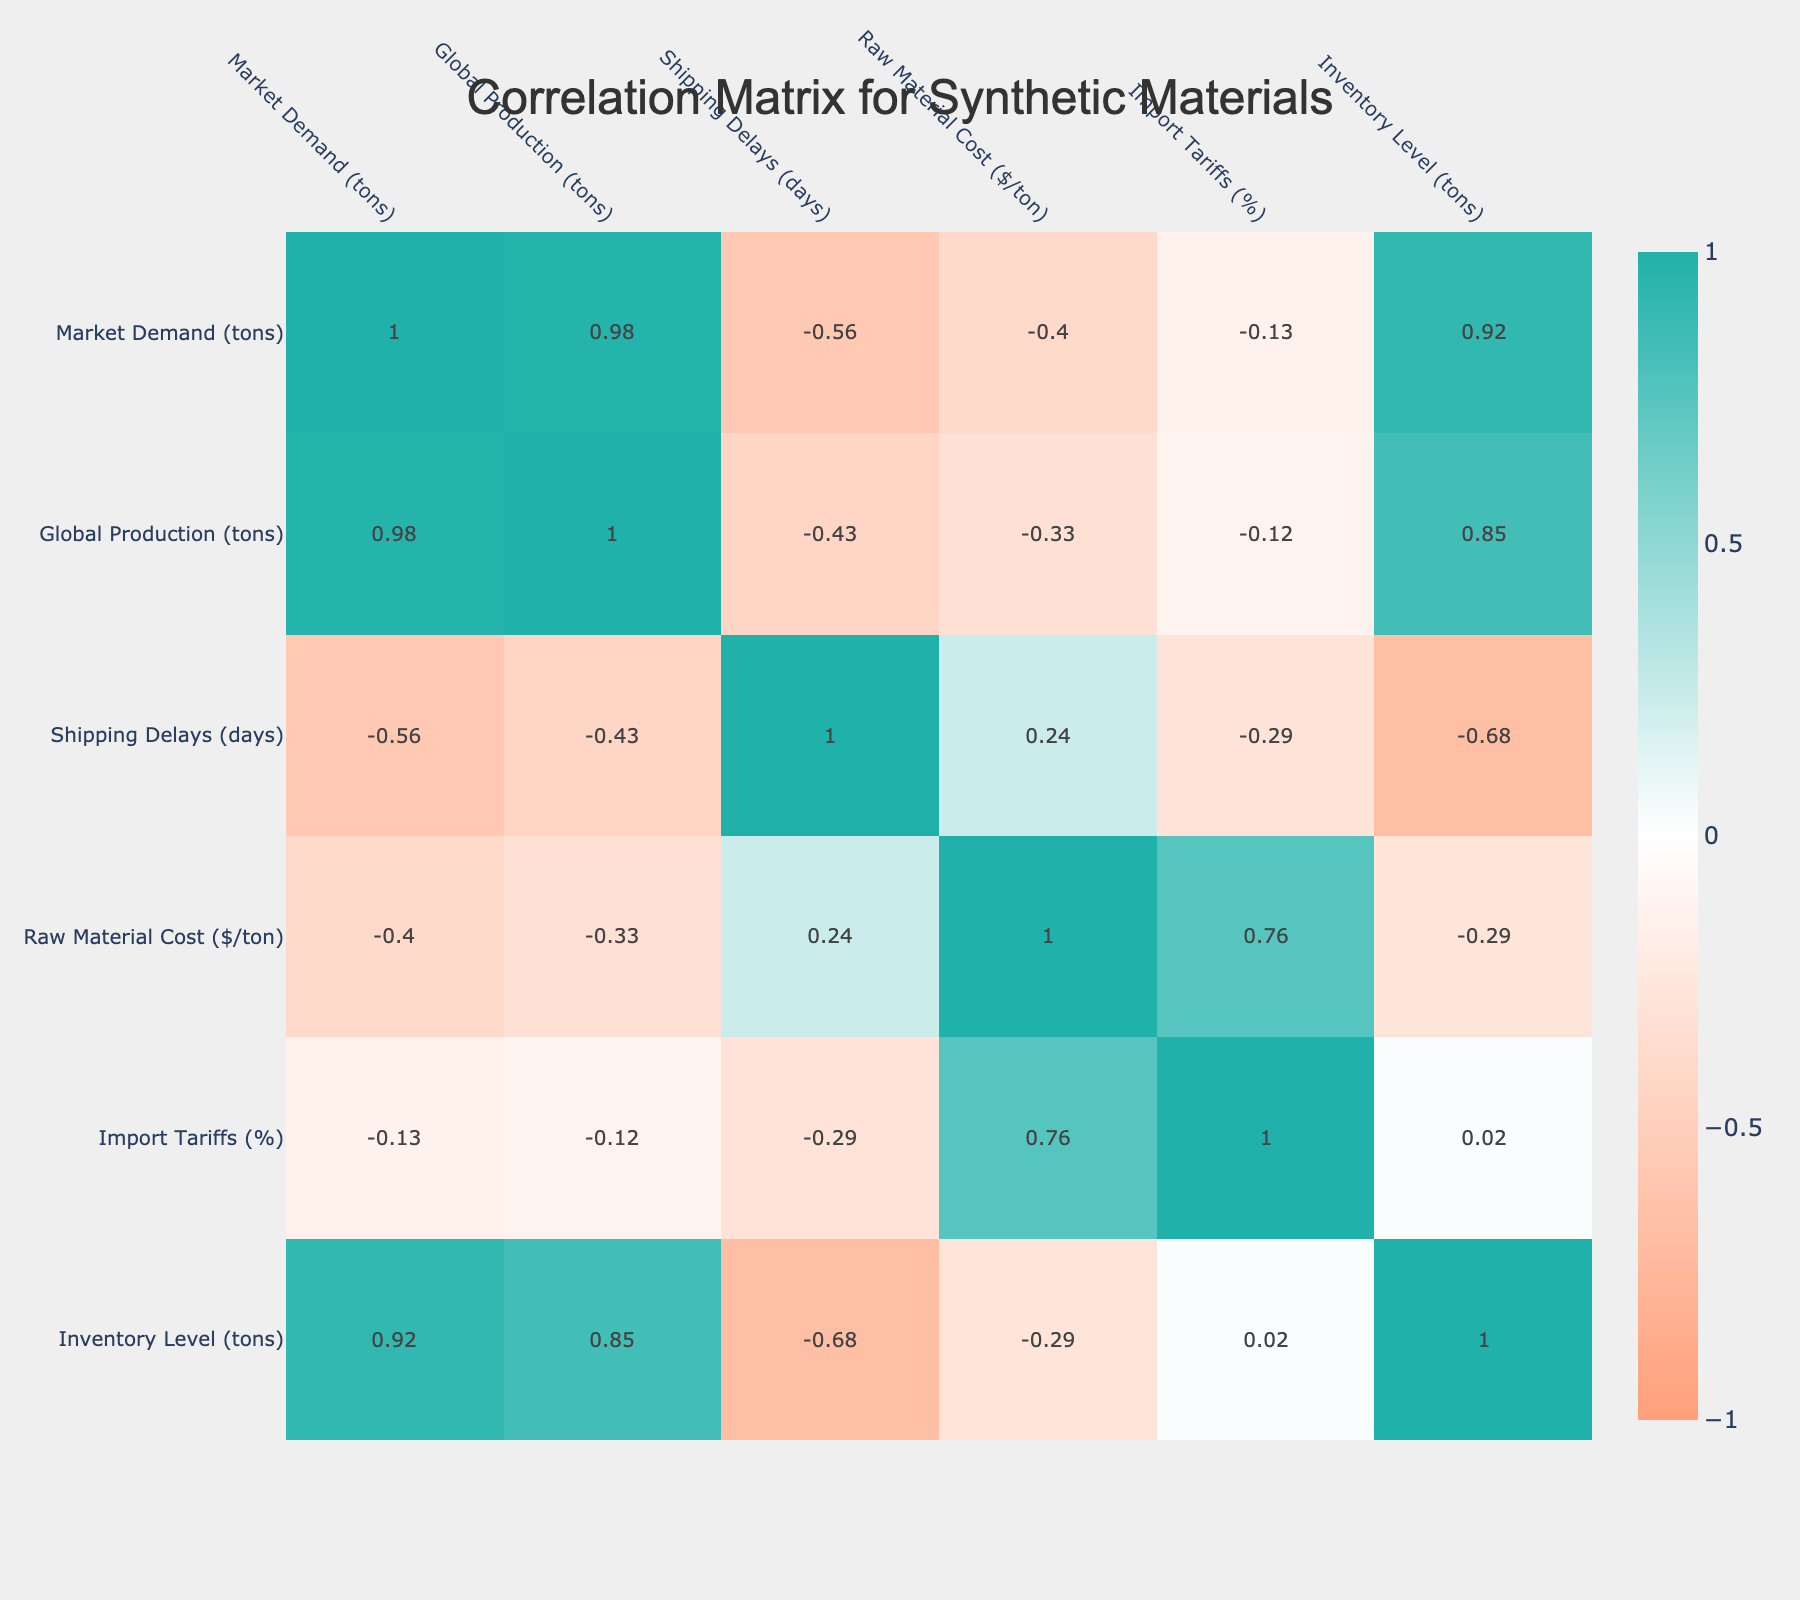What is the market demand for Polypropylene? The market demand for Polypropylene can be found directly in the table under the "Market Demand (tons)" column for Polypropylene. The value is 120 tons.
Answer: 120 tons What is the shipping delay associated with Acrylic? To find the shipping delay for Acrylic, look at the "Shipping Delays (days)" column for the Acrylic category, which shows a value of 25 days.
Answer: 25 days True or False: The Inventory Level for Polyurethane is greater than that for Polystyrene. For Polyurethane, the Inventory Level is 15 tons and for Polystyrene, it is 30 tons. Since 15 is not greater than 30, the statement is false.
Answer: False What is the average raw material cost for all categories listed? To calculate the average raw material cost, sum the cost values: (1200 + 1300 + 1250 + 1100 + 1400 + 1500 + 1350 + 1550) = 10900. There are 8 categories, so the average is 10900 / 8 = 1362.5.
Answer: 1362.5 What is the highest market demand for a category listed in the table? By checking the "Market Demand (tons)" column, Polyethylene has the highest demand listed at 150 tons.
Answer: 150 tons Which two categories have the closest shipping delays? Reviewing the shipping delays, Polypropylene has 15 days and Polystyrene has 12 days. The closest delays are between Polypropylene (15 days) and Polystyrene (12 days).
Answer: Polypropylene and Polystyrene Calculate the difference in inventory levels between the highest and lowest levels. The highest inventory level is for Polypropylene at 40 tons and the lowest is for Acrylic at 10 tons. The difference is 40 - 10 = 30 tons.
Answer: 30 tons True or False: The Shipping Delays for Nylon and Polyvinyl Chloride are equal. From the table, Nylon has a shipping delay of 30 days and Polyvinyl Chloride has 20 days. Since these values are different, the statement is false.
Answer: False What is the combined market demand for Composite Materials and Polyurethane? For Composite Materials, the market demand is 110 tons and for Polyurethane, it is 70 tons. The combined demand is 110 + 70 = 180 tons.
Answer: 180 tons 